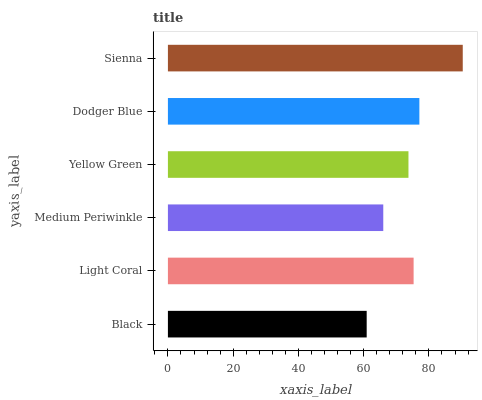Is Black the minimum?
Answer yes or no. Yes. Is Sienna the maximum?
Answer yes or no. Yes. Is Light Coral the minimum?
Answer yes or no. No. Is Light Coral the maximum?
Answer yes or no. No. Is Light Coral greater than Black?
Answer yes or no. Yes. Is Black less than Light Coral?
Answer yes or no. Yes. Is Black greater than Light Coral?
Answer yes or no. No. Is Light Coral less than Black?
Answer yes or no. No. Is Light Coral the high median?
Answer yes or no. Yes. Is Yellow Green the low median?
Answer yes or no. Yes. Is Medium Periwinkle the high median?
Answer yes or no. No. Is Black the low median?
Answer yes or no. No. 